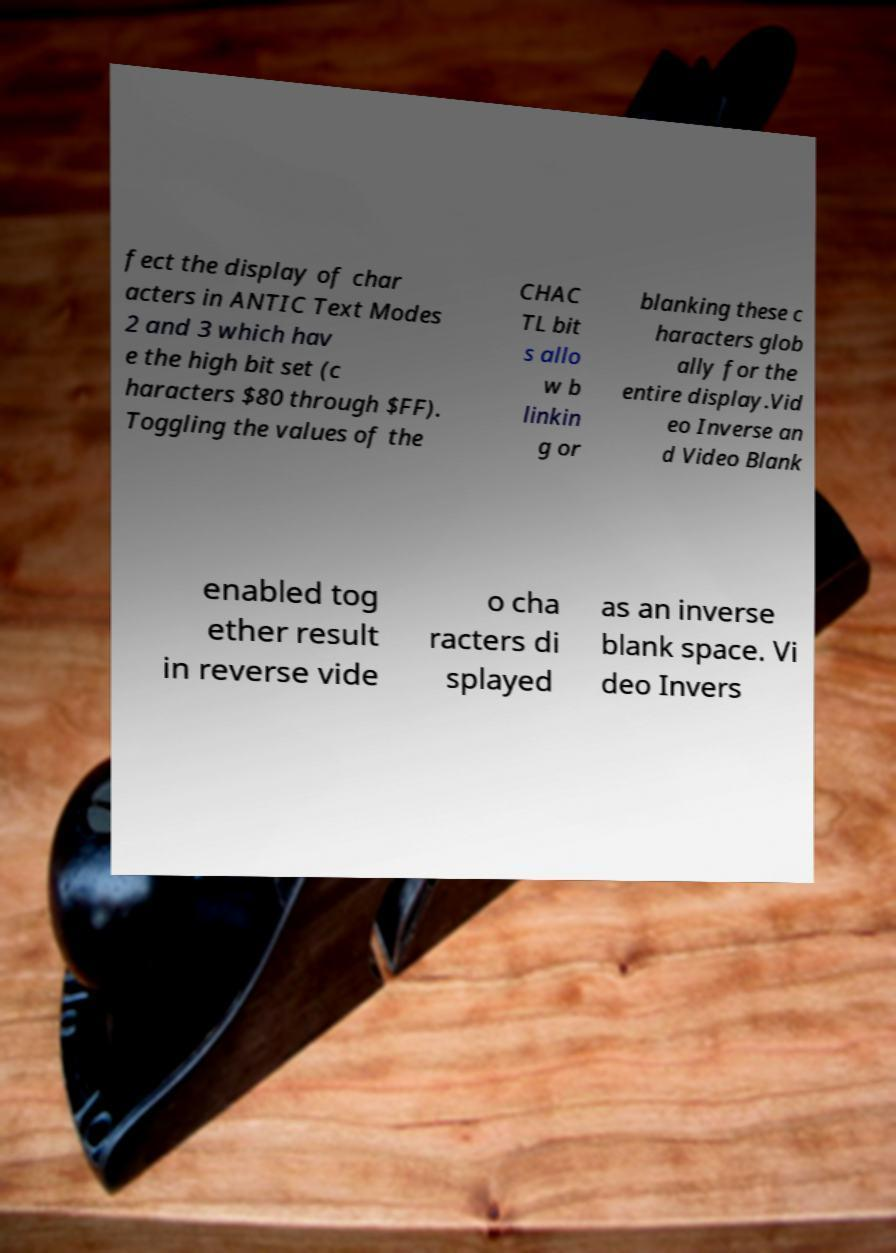What messages or text are displayed in this image? I need them in a readable, typed format. fect the display of char acters in ANTIC Text Modes 2 and 3 which hav e the high bit set (c haracters $80 through $FF). Toggling the values of the CHAC TL bit s allo w b linkin g or blanking these c haracters glob ally for the entire display.Vid eo Inverse an d Video Blank enabled tog ether result in reverse vide o cha racters di splayed as an inverse blank space. Vi deo Invers 